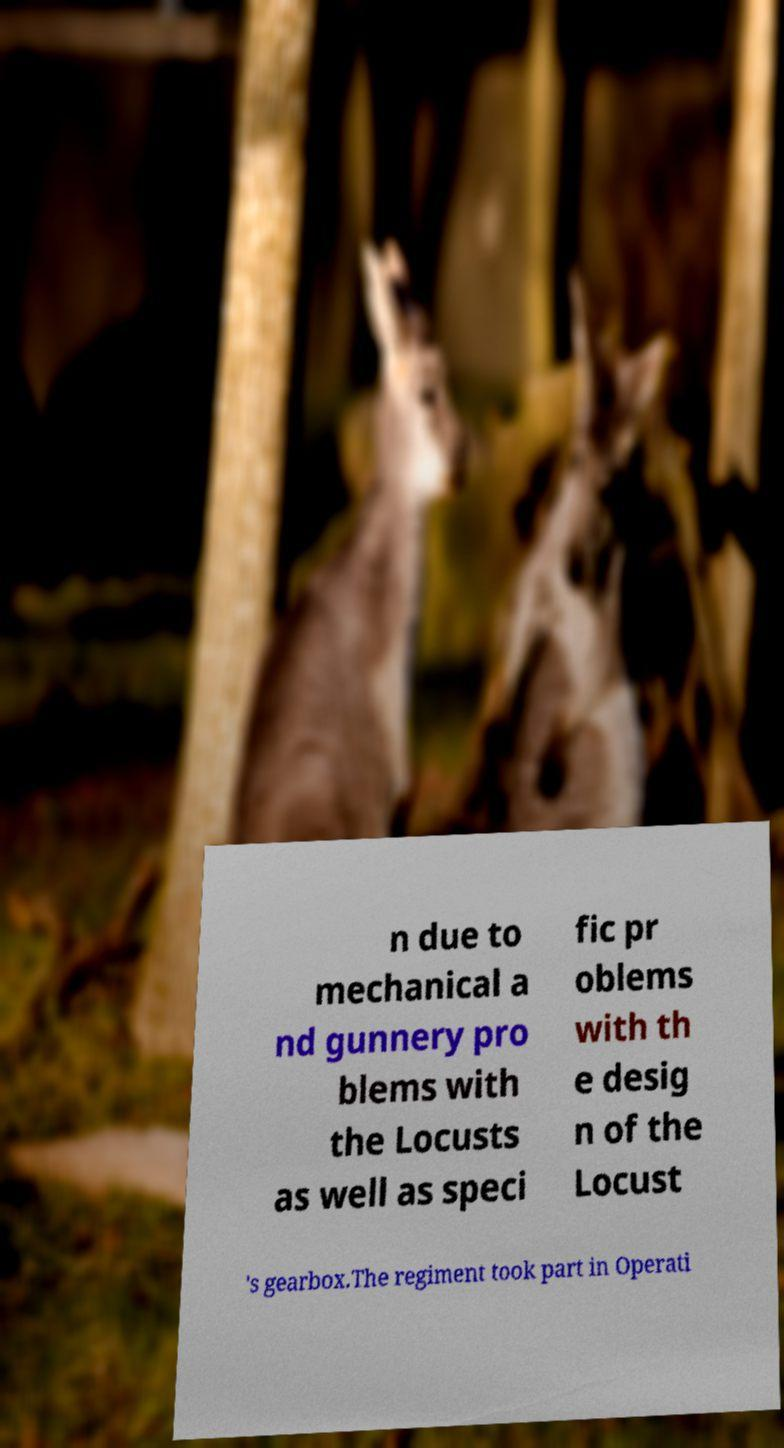Can you read and provide the text displayed in the image?This photo seems to have some interesting text. Can you extract and type it out for me? n due to mechanical a nd gunnery pro blems with the Locusts as well as speci fic pr oblems with th e desig n of the Locust 's gearbox.The regiment took part in Operati 